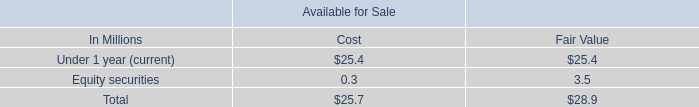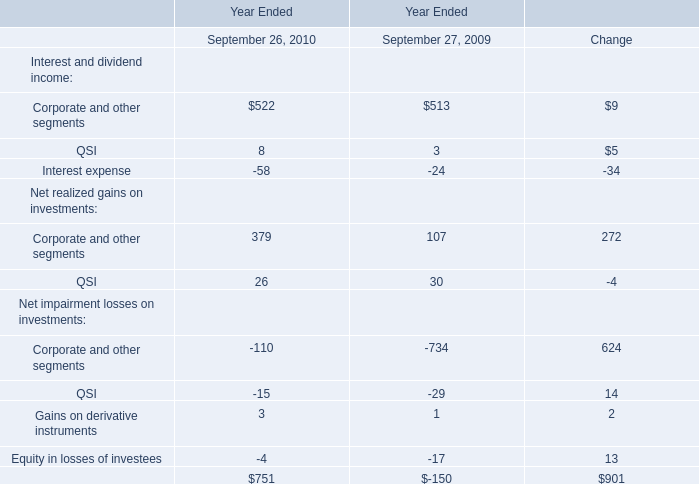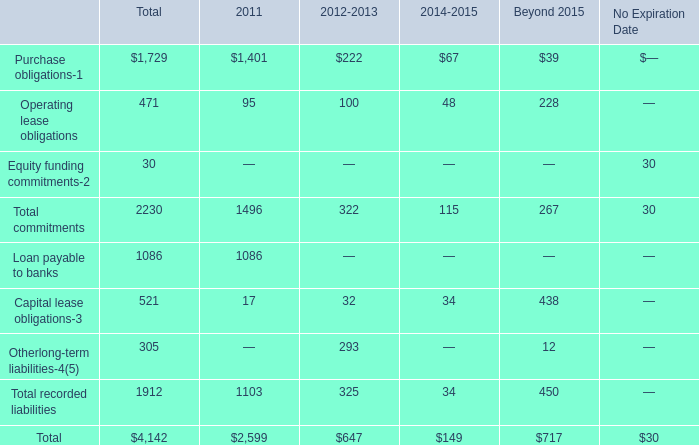what is the difference between carrying amounts of long-term debt and fair value? 
Computations: (14268.8 - 14169.7)
Answer: 99.1. 